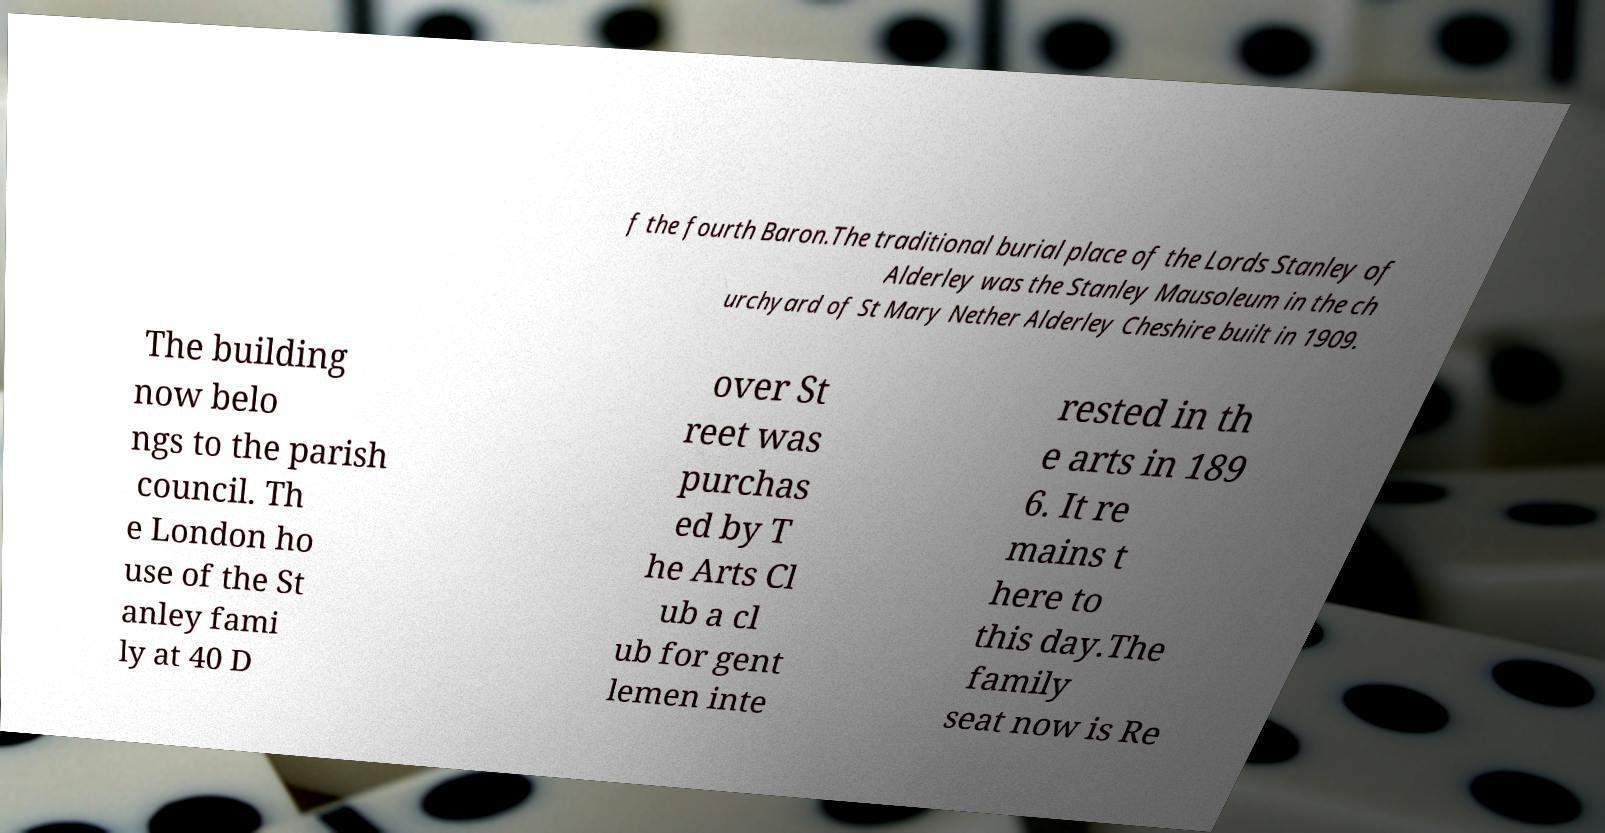I need the written content from this picture converted into text. Can you do that? f the fourth Baron.The traditional burial place of the Lords Stanley of Alderley was the Stanley Mausoleum in the ch urchyard of St Mary Nether Alderley Cheshire built in 1909. The building now belo ngs to the parish council. Th e London ho use of the St anley fami ly at 40 D over St reet was purchas ed by T he Arts Cl ub a cl ub for gent lemen inte rested in th e arts in 189 6. It re mains t here to this day.The family seat now is Re 